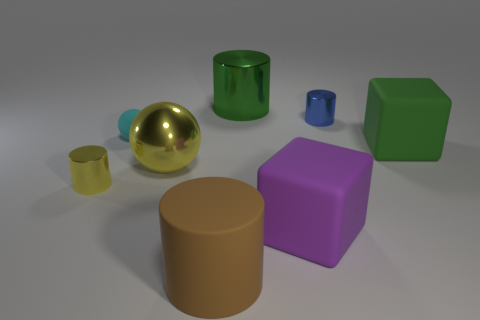The cylinder that is the same color as the large metallic sphere is what size?
Offer a terse response. Small. Are there any shiny spheres of the same size as the purple rubber cube?
Your response must be concise. Yes. Is the material of the large yellow thing the same as the tiny cylinder in front of the big green matte cube?
Your response must be concise. Yes. Are there more small cyan matte things than tiny purple things?
Offer a terse response. Yes. What number of cubes are either yellow things or tiny yellow shiny things?
Offer a terse response. 0. The big metal sphere is what color?
Your answer should be very brief. Yellow. Does the cube that is left of the green rubber block have the same size as the cylinder that is on the left side of the yellow shiny ball?
Offer a very short reply. No. Are there fewer large brown rubber objects than big gray balls?
Provide a short and direct response. No. How many green blocks are left of the big brown rubber cylinder?
Offer a terse response. 0. What is the material of the tiny blue cylinder?
Keep it short and to the point. Metal. 